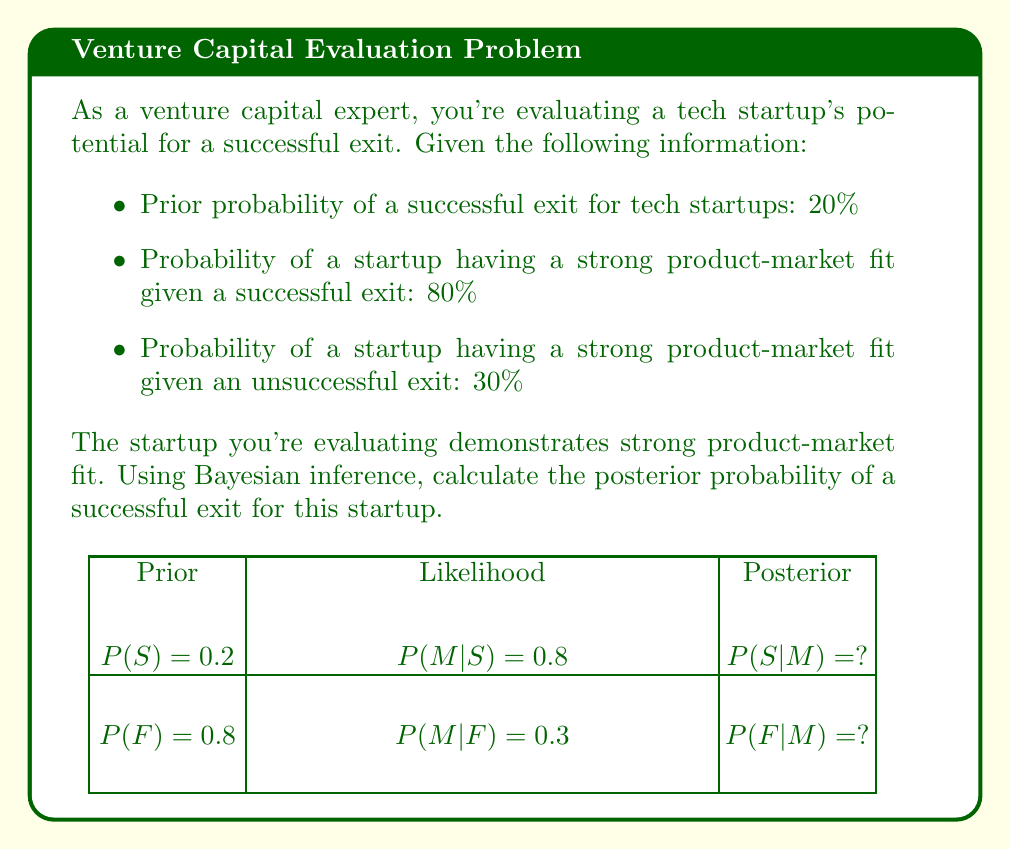Solve this math problem. Let's approach this problem using Bayes' theorem:

1) Define our events:
   S: Successful exit
   M: Strong product-market fit

2) We're given:
   $P(S) = 0.2$ (prior probability of success)
   $P(M|S) = 0.8$ (likelihood of strong fit given success)
   $P(M|F) = 0.3$ (likelihood of strong fit given failure)

3) Bayes' theorem states:

   $$P(S|M) = \frac{P(M|S) \cdot P(S)}{P(M)}$$

4) We need to calculate $P(M)$ using the law of total probability:

   $$P(M) = P(M|S) \cdot P(S) + P(M|F) \cdot P(F)$$

5) Calculate $P(F)$:
   $P(F) = 1 - P(S) = 1 - 0.2 = 0.8$

6) Now we can calculate $P(M)$:
   $$P(M) = 0.8 \cdot 0.2 + 0.3 \cdot 0.8 = 0.16 + 0.24 = 0.4$$

7) Plug everything into Bayes' theorem:

   $$P(S|M) = \frac{0.8 \cdot 0.2}{0.4} = \frac{0.16}{0.4} = 0.4$$

Therefore, the posterior probability of a successful exit given strong product-market fit is 40%.
Answer: $0.4$ or $40\%$ 